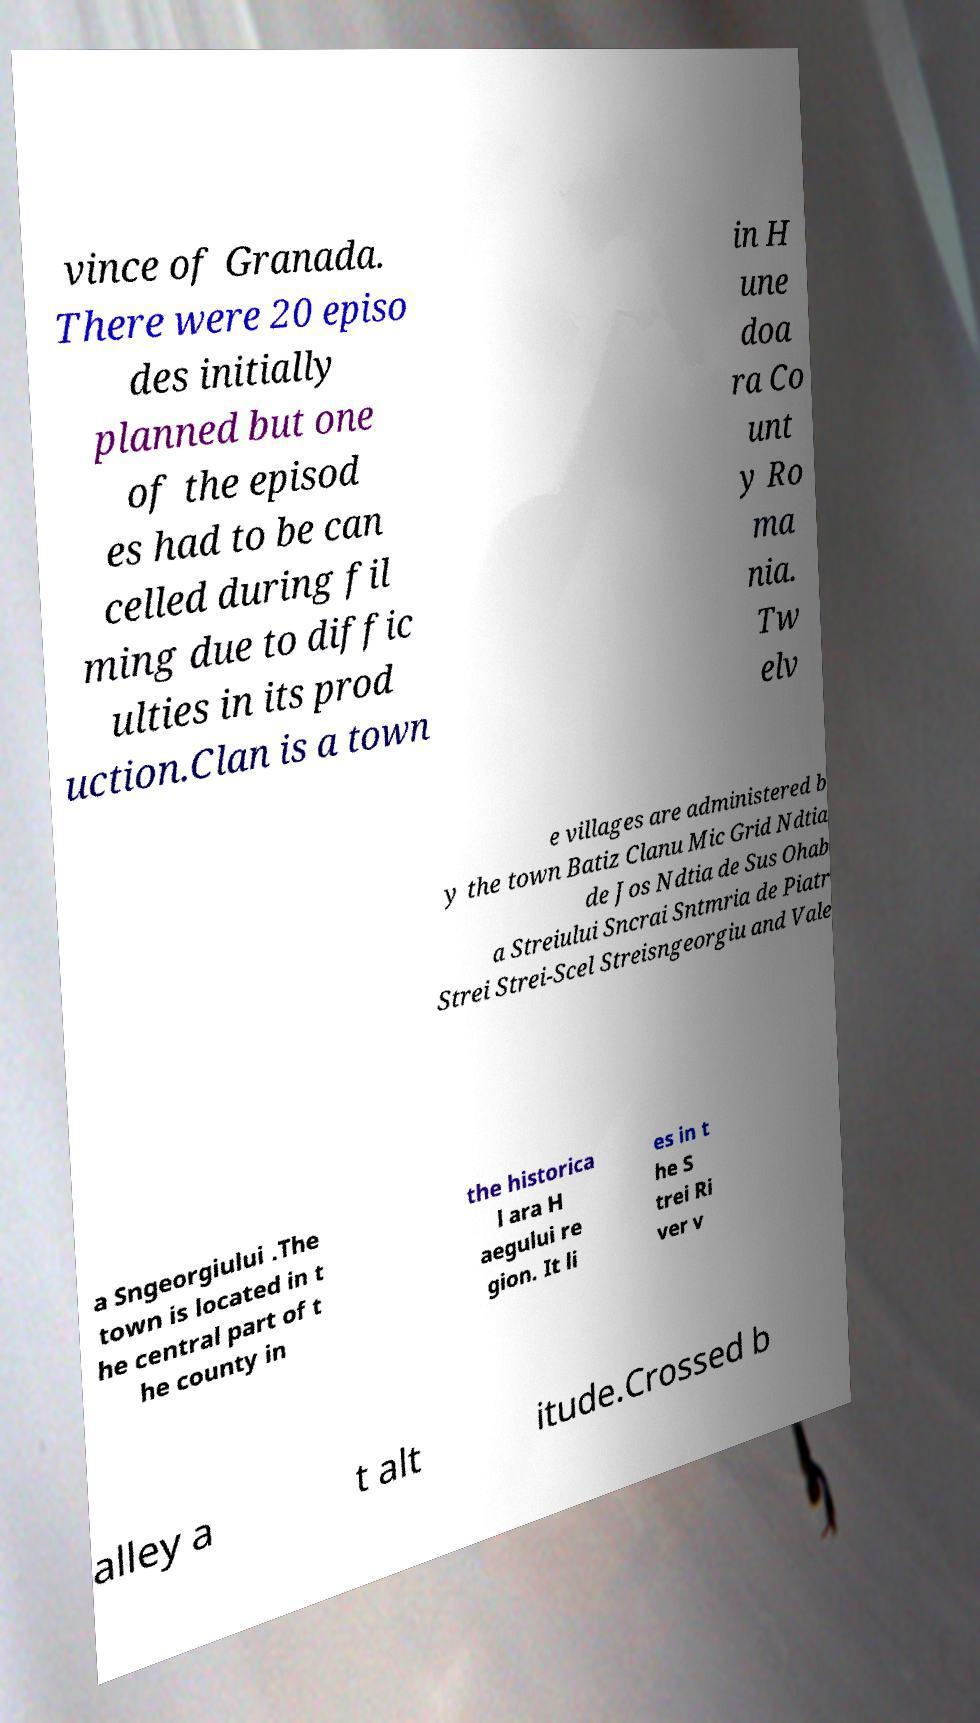Please identify and transcribe the text found in this image. vince of Granada. There were 20 episo des initially planned but one of the episod es had to be can celled during fil ming due to diffic ulties in its prod uction.Clan is a town in H une doa ra Co unt y Ro ma nia. Tw elv e villages are administered b y the town Batiz Clanu Mic Grid Ndtia de Jos Ndtia de Sus Ohab a Streiului Sncrai Sntmria de Piatr Strei Strei-Scel Streisngeorgiu and Vale a Sngeorgiului .The town is located in t he central part of t he county in the historica l ara H aegului re gion. It li es in t he S trei Ri ver v alley a t alt itude.Crossed b 